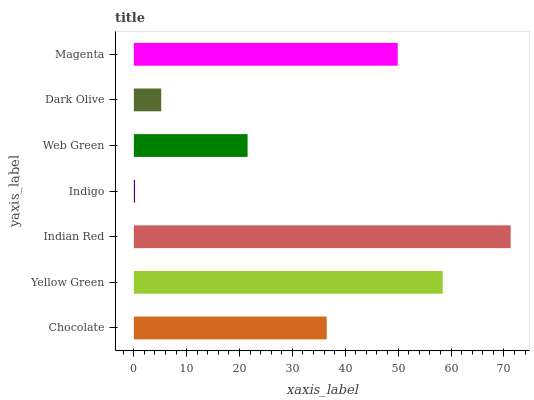Is Indigo the minimum?
Answer yes or no. Yes. Is Indian Red the maximum?
Answer yes or no. Yes. Is Yellow Green the minimum?
Answer yes or no. No. Is Yellow Green the maximum?
Answer yes or no. No. Is Yellow Green greater than Chocolate?
Answer yes or no. Yes. Is Chocolate less than Yellow Green?
Answer yes or no. Yes. Is Chocolate greater than Yellow Green?
Answer yes or no. No. Is Yellow Green less than Chocolate?
Answer yes or no. No. Is Chocolate the high median?
Answer yes or no. Yes. Is Chocolate the low median?
Answer yes or no. Yes. Is Web Green the high median?
Answer yes or no. No. Is Indigo the low median?
Answer yes or no. No. 